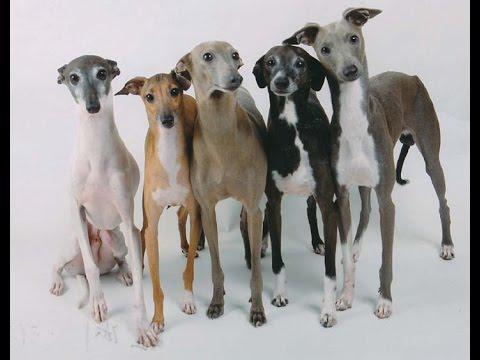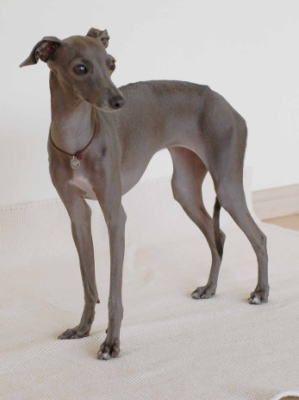The first image is the image on the left, the second image is the image on the right. Assess this claim about the two images: "An image contains a row of at least four dogs.". Correct or not? Answer yes or no. Yes. The first image is the image on the left, the second image is the image on the right. Given the left and right images, does the statement "There is 1 dog standing outside." hold true? Answer yes or no. No. 